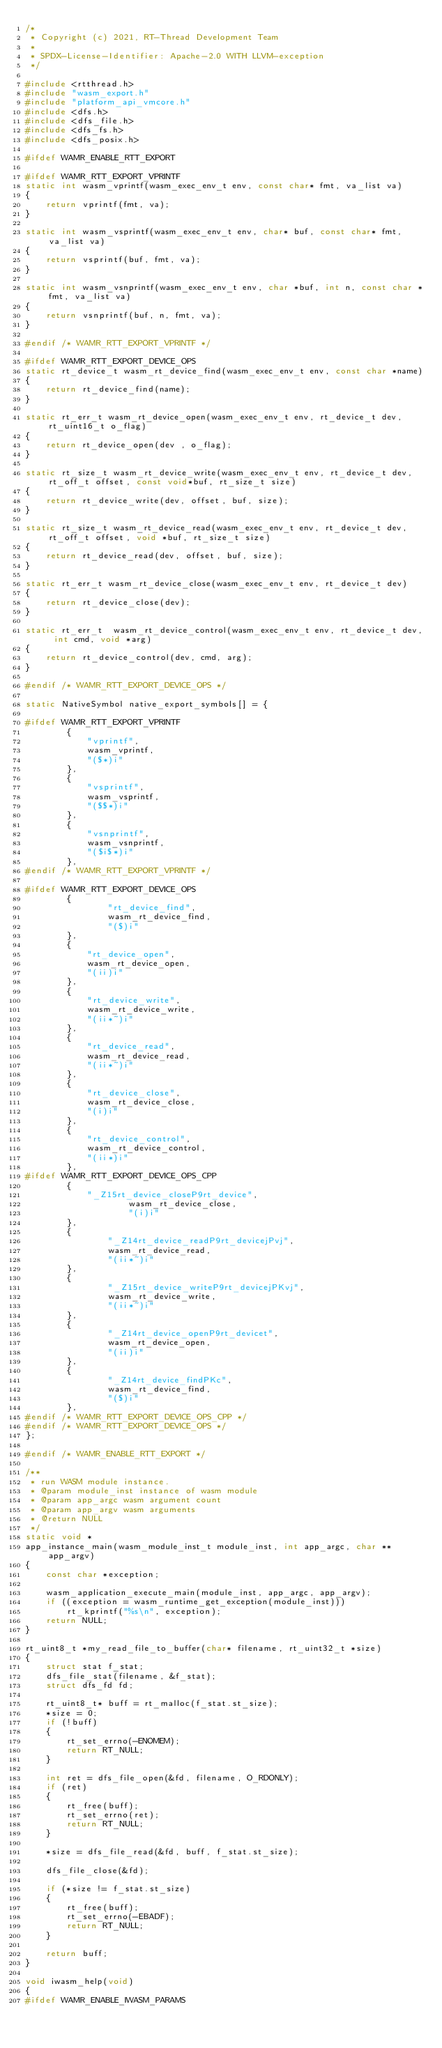<code> <loc_0><loc_0><loc_500><loc_500><_C_>/*
 * Copyright (c) 2021, RT-Thread Development Team
 *
 * SPDX-License-Identifier: Apache-2.0 WITH LLVM-exception
 */

#include <rtthread.h>
#include "wasm_export.h"
#include "platform_api_vmcore.h"
#include <dfs.h>
#include <dfs_file.h>
#include <dfs_fs.h>
#include <dfs_posix.h>

#ifdef WAMR_ENABLE_RTT_EXPORT

#ifdef WAMR_RTT_EXPORT_VPRINTF
static int wasm_vprintf(wasm_exec_env_t env, const char* fmt, va_list va)
{
    return vprintf(fmt, va);
}

static int wasm_vsprintf(wasm_exec_env_t env, char* buf, const char* fmt, va_list va)
{
    return vsprintf(buf, fmt, va);
}

static int wasm_vsnprintf(wasm_exec_env_t env, char *buf, int n, const char *fmt, va_list va)
{
    return vsnprintf(buf, n, fmt, va);
}

#endif /* WAMR_RTT_EXPORT_VPRINTF */

#ifdef WAMR_RTT_EXPORT_DEVICE_OPS
static rt_device_t wasm_rt_device_find(wasm_exec_env_t env, const char *name)
{
    return rt_device_find(name);
}

static rt_err_t wasm_rt_device_open(wasm_exec_env_t env, rt_device_t dev, rt_uint16_t o_flag)
{
    return rt_device_open(dev , o_flag);
}

static rt_size_t wasm_rt_device_write(wasm_exec_env_t env, rt_device_t dev, rt_off_t offset, const void*buf, rt_size_t size)
{
    return rt_device_write(dev, offset, buf, size);
}

static rt_size_t wasm_rt_device_read(wasm_exec_env_t env, rt_device_t dev, rt_off_t offset, void *buf, rt_size_t size)
{
    return rt_device_read(dev, offset, buf, size);
}

static rt_err_t wasm_rt_device_close(wasm_exec_env_t env, rt_device_t dev)
{
    return rt_device_close(dev);
}

static rt_err_t  wasm_rt_device_control(wasm_exec_env_t env, rt_device_t dev, int cmd, void *arg)
{
    return rt_device_control(dev, cmd, arg);
}

#endif /* WAMR_RTT_EXPORT_DEVICE_OPS */

static NativeSymbol native_export_symbols[] = {

#ifdef WAMR_RTT_EXPORT_VPRINTF
        {
            "vprintf",
            wasm_vprintf,
            "($*)i"
        },
        {
            "vsprintf",
            wasm_vsprintf,
            "($$*)i"
        },
        {
            "vsnprintf",
            wasm_vsnprintf,
            "($i$*)i"
        },
#endif /* WAMR_RTT_EXPORT_VPRINTF */

#ifdef WAMR_RTT_EXPORT_DEVICE_OPS
        {
                "rt_device_find",
                wasm_rt_device_find,
                "($)i"
        },
        {
            "rt_device_open",
            wasm_rt_device_open,
            "(ii)i"
        },
        {
            "rt_device_write",
            wasm_rt_device_write,
            "(ii*~)i"
        },
        {
            "rt_device_read",
            wasm_rt_device_read,
            "(ii*~)i"
        },
        {
            "rt_device_close",
            wasm_rt_device_close,
            "(i)i"
        },
        {
            "rt_device_control",
            wasm_rt_device_control,
            "(ii*)i"
        },
#ifdef WAMR_RTT_EXPORT_DEVICE_OPS_CPP
        {
            "_Z15rt_device_closeP9rt_device",
                    wasm_rt_device_close,
                    "(i)i"
        },
        {
                "_Z14rt_device_readP9rt_devicejPvj",
                wasm_rt_device_read,
                "(ii*~)i"
        },
        {
                "_Z15rt_device_writeP9rt_devicejPKvj",
                wasm_rt_device_write,
                "(ii*~)i"
        },
        {
                "_Z14rt_device_openP9rt_devicet",
                wasm_rt_device_open,
                "(ii)i"
        },
        {
                "_Z14rt_device_findPKc",
                wasm_rt_device_find,
                "($)i"
        },
#endif /* WAMR_RTT_EXPORT_DEVICE_OPS_CPP */
#endif /* WAMR_RTT_EXPORT_DEVICE_OPS */
};

#endif /* WAMR_ENABLE_RTT_EXPORT */

/**
 * run WASM module instance.
 * @param module_inst instance of wasm module
 * @param app_argc wasm argument count
 * @param app_argv wasm arguments
 * @return NULL
 */
static void *
app_instance_main(wasm_module_inst_t module_inst, int app_argc, char **app_argv)
{
    const char *exception;

    wasm_application_execute_main(module_inst, app_argc, app_argv);
    if ((exception = wasm_runtime_get_exception(module_inst)))
        rt_kprintf("%s\n", exception);
    return NULL;
}

rt_uint8_t *my_read_file_to_buffer(char* filename, rt_uint32_t *size)
{
    struct stat f_stat;
    dfs_file_stat(filename, &f_stat);
    struct dfs_fd fd;

    rt_uint8_t* buff = rt_malloc(f_stat.st_size);
    *size = 0;
    if (!buff)
    {
        rt_set_errno(-ENOMEM);
        return RT_NULL;
    }

    int ret = dfs_file_open(&fd, filename, O_RDONLY);
    if (ret)
    {
        rt_free(buff);
        rt_set_errno(ret);
        return RT_NULL;
    }

    *size = dfs_file_read(&fd, buff, f_stat.st_size);

    dfs_file_close(&fd);

    if (*size != f_stat.st_size)
    {
        rt_free(buff);
        rt_set_errno(-EBADF);
        return RT_NULL;
    }

    return buff;
}

void iwasm_help(void)
{
#ifdef WAMR_ENABLE_IWASM_PARAMS</code> 